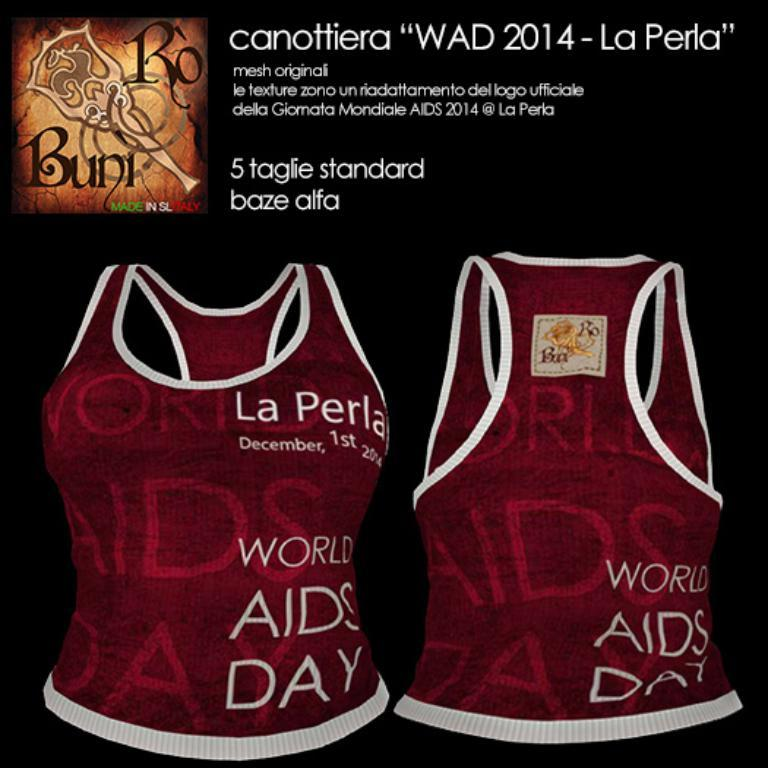<image>
Write a terse but informative summary of the picture. A foreign advertisement for World AIDS Day tank tops. 